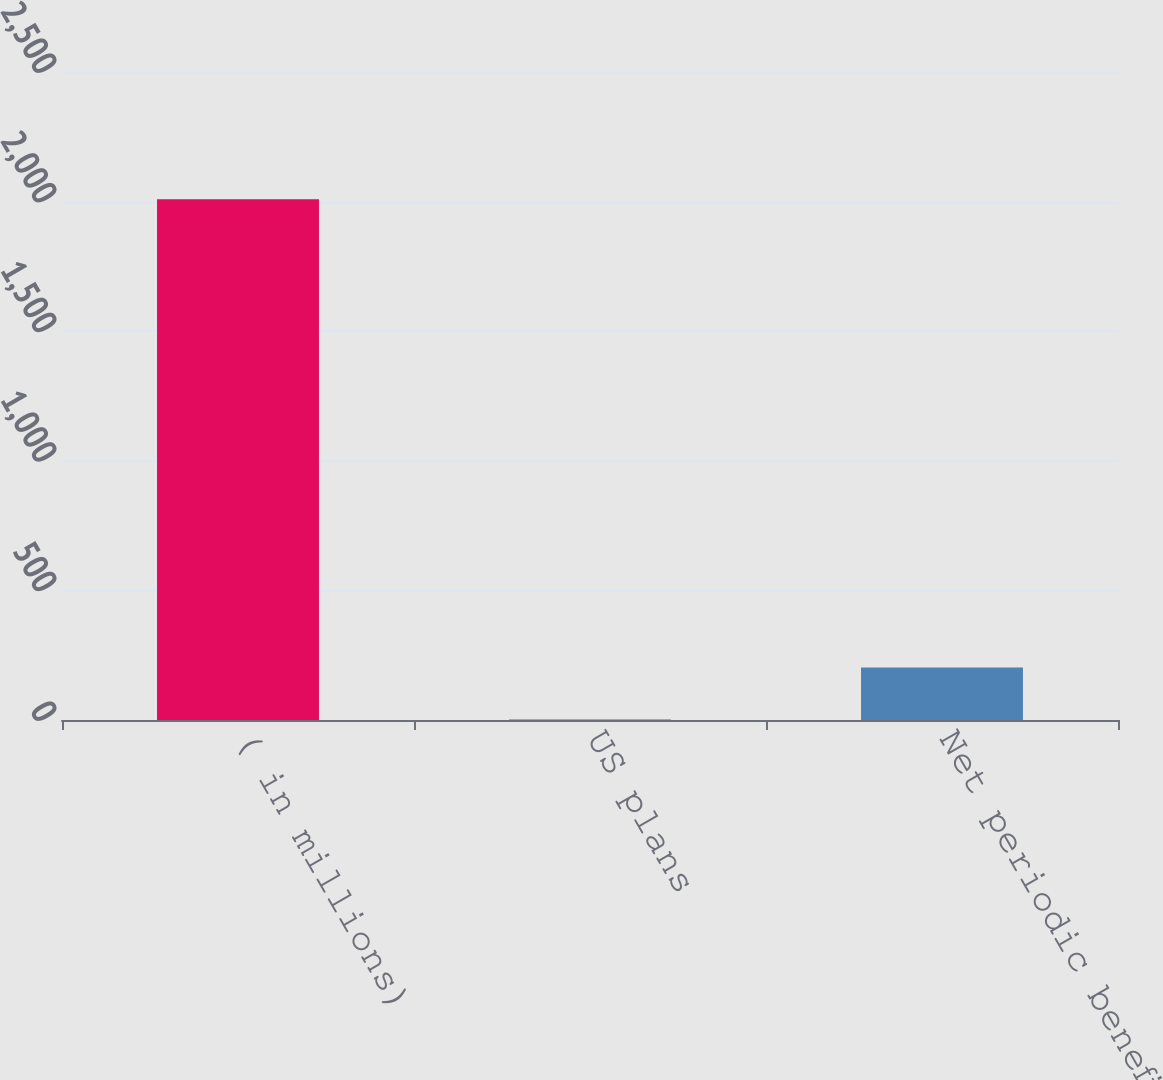Convert chart. <chart><loc_0><loc_0><loc_500><loc_500><bar_chart><fcel>( in millions)<fcel>US plans<fcel>Net periodic benefit cost<nl><fcel>2009<fcel>1.8<fcel>202.52<nl></chart> 